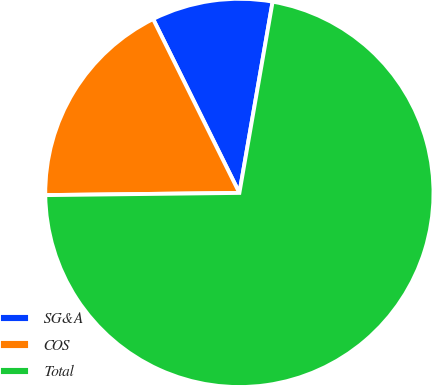Convert chart. <chart><loc_0><loc_0><loc_500><loc_500><pie_chart><fcel>SG&A<fcel>COS<fcel>Total<nl><fcel>10.07%<fcel>17.85%<fcel>72.08%<nl></chart> 